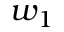<formula> <loc_0><loc_0><loc_500><loc_500>w _ { 1 }</formula> 